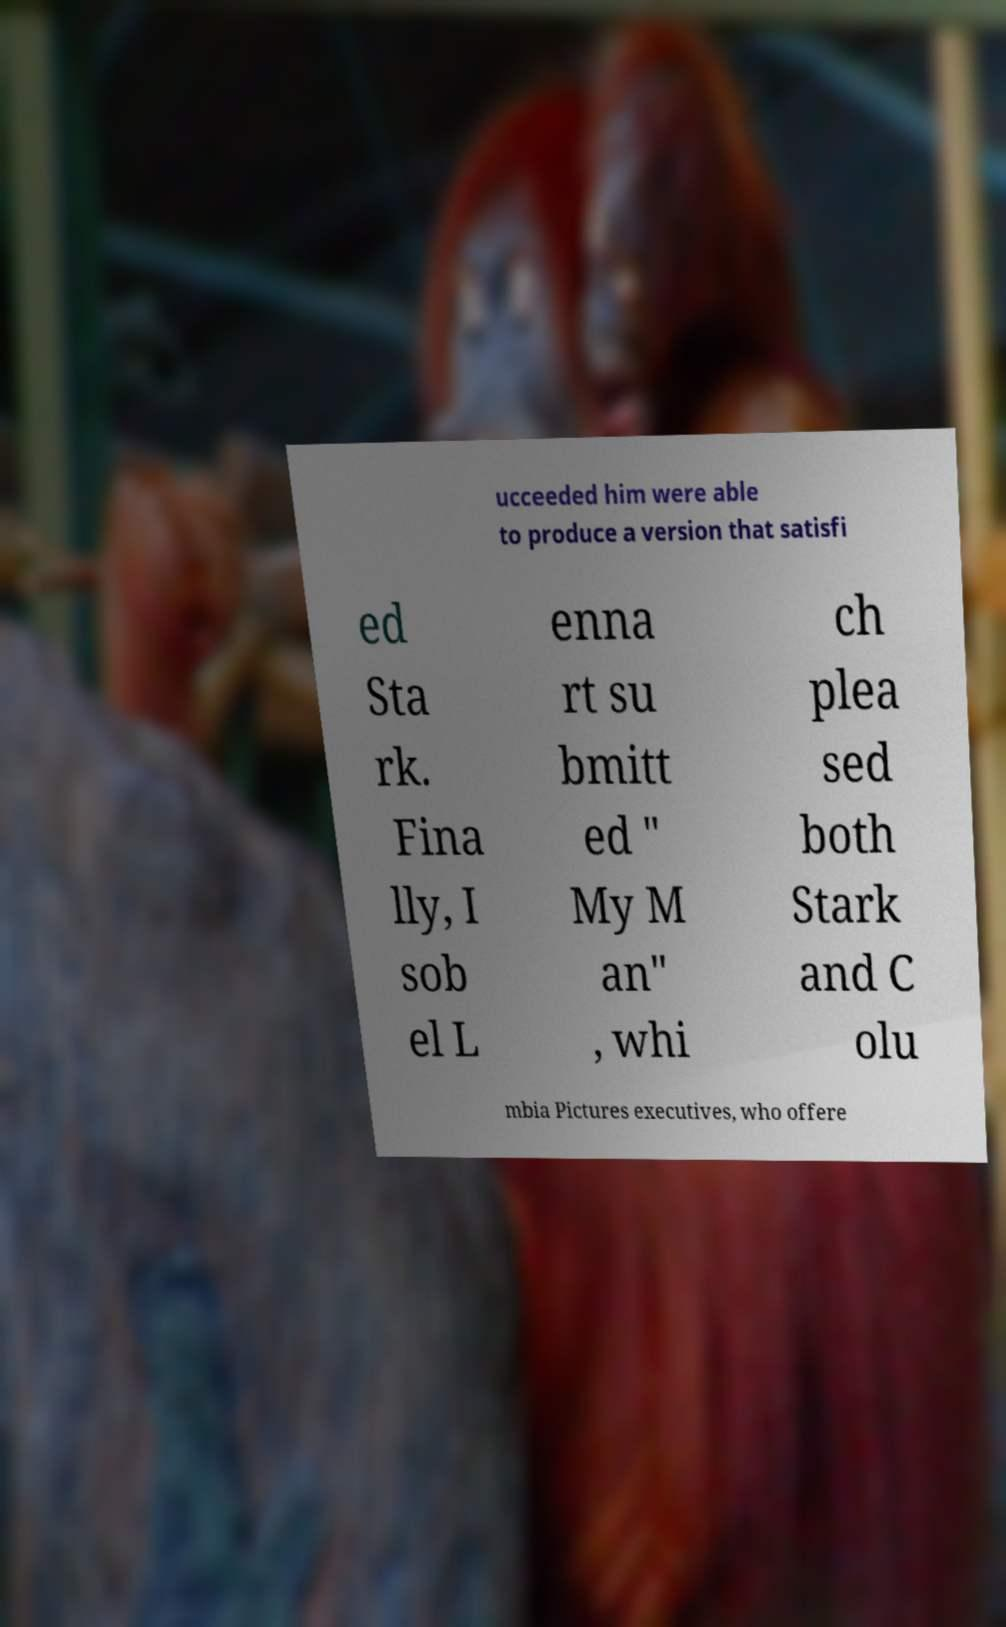Could you assist in decoding the text presented in this image and type it out clearly? ucceeded him were able to produce a version that satisfi ed Sta rk. Fina lly, I sob el L enna rt su bmitt ed " My M an" , whi ch plea sed both Stark and C olu mbia Pictures executives, who offere 